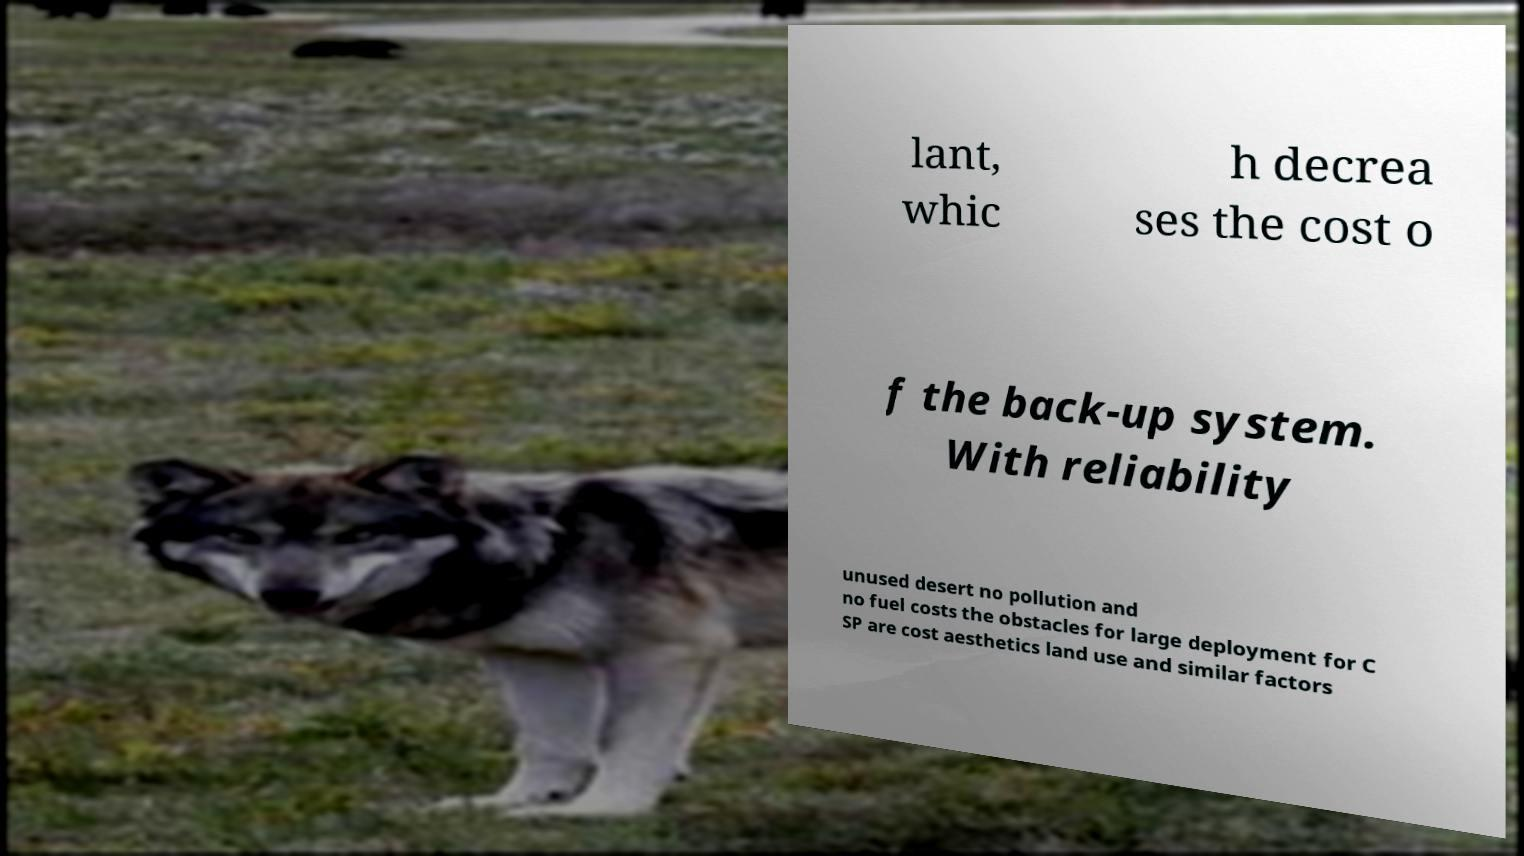Could you extract and type out the text from this image? lant, whic h decrea ses the cost o f the back-up system. With reliability unused desert no pollution and no fuel costs the obstacles for large deployment for C SP are cost aesthetics land use and similar factors 